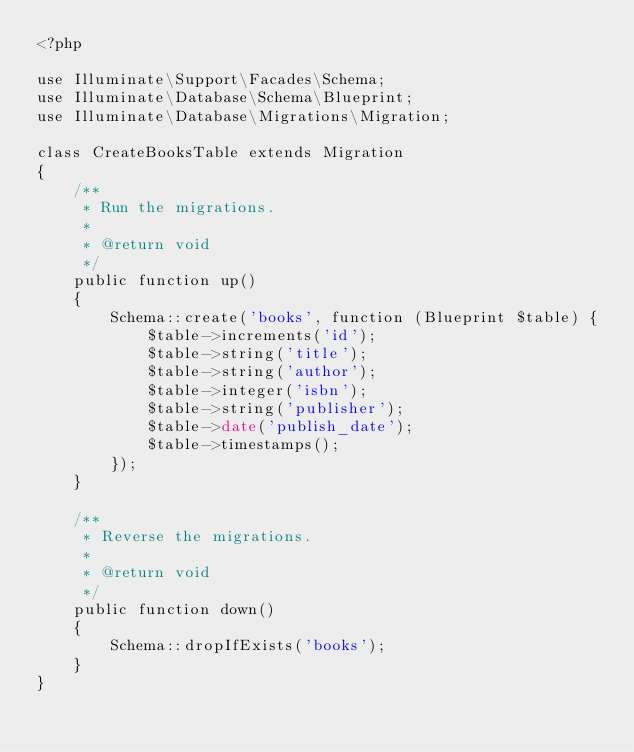Convert code to text. <code><loc_0><loc_0><loc_500><loc_500><_PHP_><?php

use Illuminate\Support\Facades\Schema;
use Illuminate\Database\Schema\Blueprint;
use Illuminate\Database\Migrations\Migration;

class CreateBooksTable extends Migration
{
    /**
     * Run the migrations.
     *
     * @return void
     */
    public function up()
    {
        Schema::create('books', function (Blueprint $table) {
            $table->increments('id');
            $table->string('title');
            $table->string('author');
            $table->integer('isbn');
            $table->string('publisher');
            $table->date('publish_date');
            $table->timestamps();
        });
    }

    /**
     * Reverse the migrations.
     *
     * @return void
     */
    public function down()
    {
        Schema::dropIfExists('books');
    }
}
</code> 